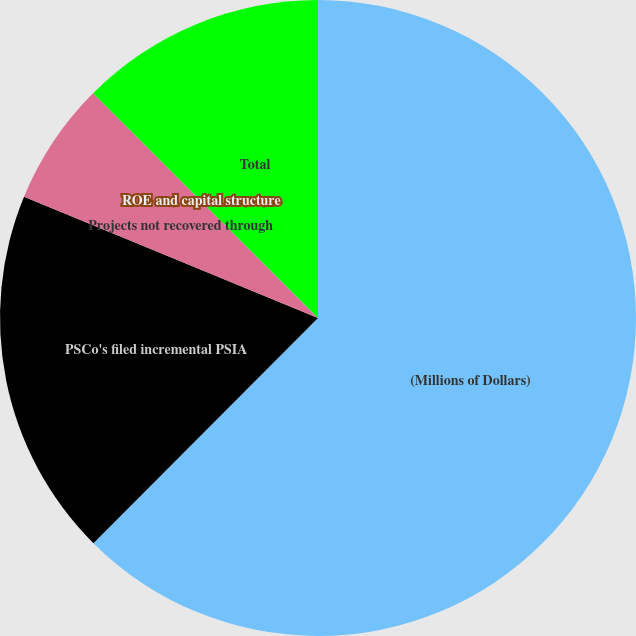<chart> <loc_0><loc_0><loc_500><loc_500><pie_chart><fcel>(Millions of Dollars)<fcel>PSCo's filed incremental PSIA<fcel>Projects not recovered through<fcel>ROE and capital structure<fcel>Total<nl><fcel>62.48%<fcel>18.75%<fcel>6.26%<fcel>0.01%<fcel>12.5%<nl></chart> 